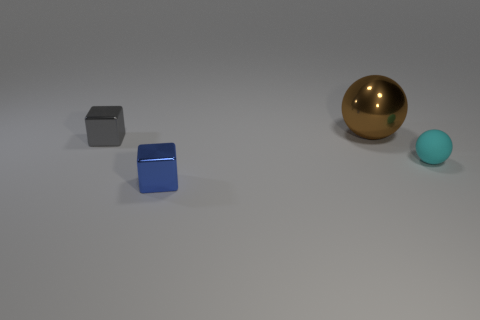Add 1 small brown blocks. How many objects exist? 5 Subtract 1 blue blocks. How many objects are left? 3 Subtract all metallic cylinders. Subtract all tiny cubes. How many objects are left? 2 Add 4 small gray cubes. How many small gray cubes are left? 5 Add 2 small gray shiny objects. How many small gray shiny objects exist? 3 